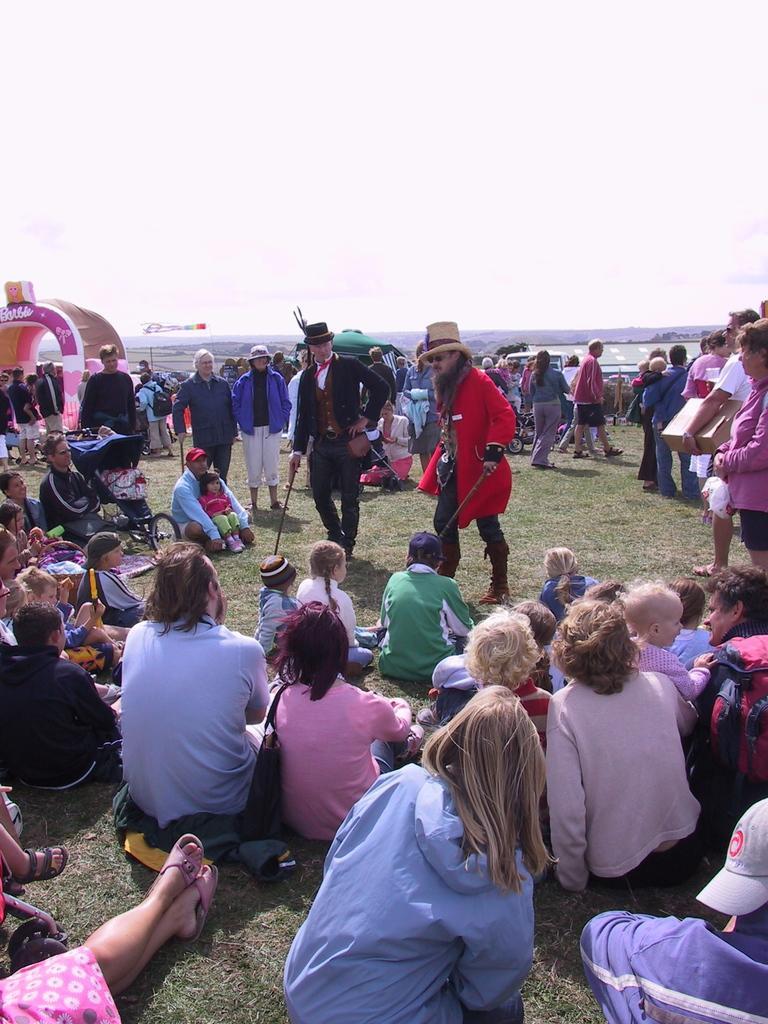How would you summarize this image in a sentence or two? In this picture i can see group of people among them some are standing and some are sitting on the ground. I can also see some objects on the ground. In the background I can see sky. 